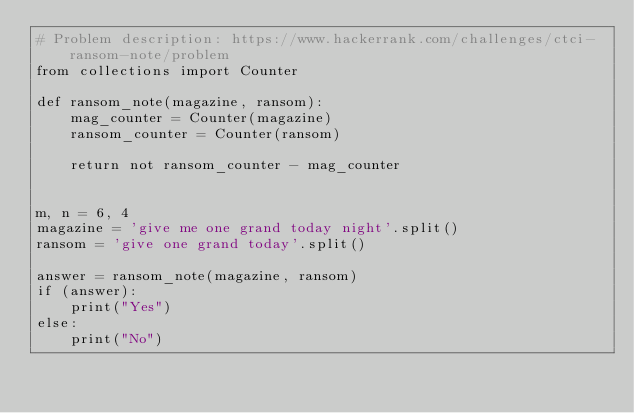Convert code to text. <code><loc_0><loc_0><loc_500><loc_500><_Python_># Problem description: https://www.hackerrank.com/challenges/ctci-ransom-note/problem
from collections import Counter

def ransom_note(magazine, ransom):
    mag_counter = Counter(magazine)
    ransom_counter = Counter(ransom)

    return not ransom_counter - mag_counter


m, n = 6, 4
magazine = 'give me one grand today night'.split()
ransom = 'give one grand today'.split()

answer = ransom_note(magazine, ransom)
if (answer):
    print("Yes")
else:
    print("No")

</code> 